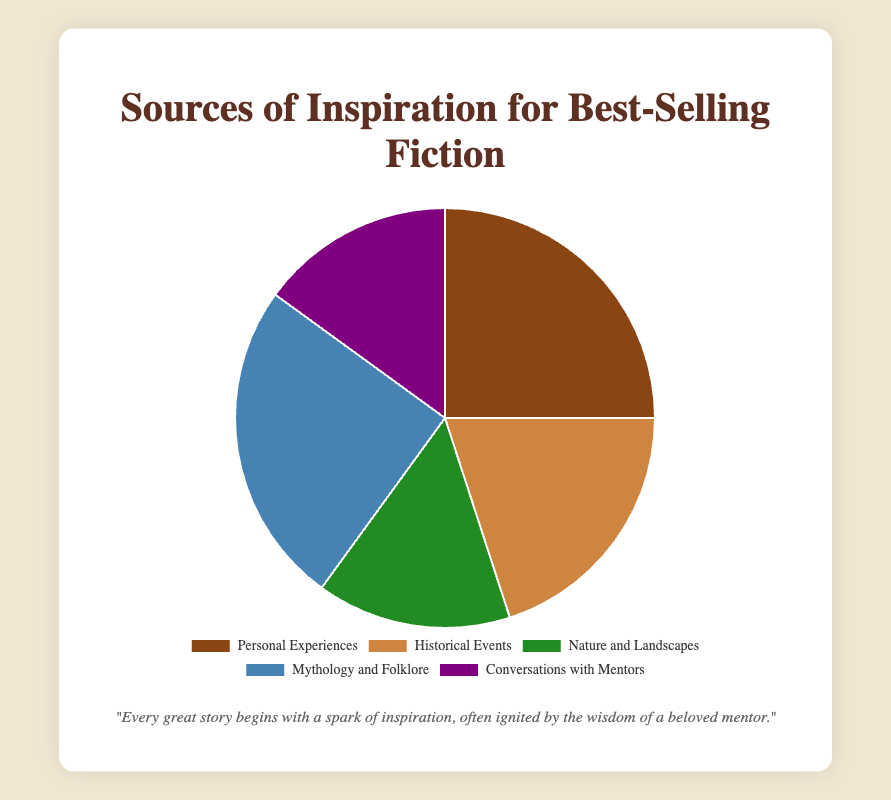What's the most common source of inspiration? The figure shows various percentages for different sources of inspiration, and the highest percentage is the one used to determine the most common source. Both "Personal Experiences" and "Mythology and Folklore" share the highest percentage of 25% each.
Answer: Personal Experiences and Mythology and Folklore Which two sources are equally common and what percentage do they each have? By observing the figure, "Nature and Landscapes" and "Conversations with Mentors" both have the same percentage.
Answer: Nature and Landscapes and Conversations with Mentors, 15% What is the combined percentage of inspiration from "Personal Experiences" and "Mythology and Folklore"? The figure shows that both "Personal Experiences" and "Mythology and Folklore" each contribute 25%, thus combined they contribute 25% + 25% = 50%.
Answer: 50% What is the percentage difference between the most common and least common sources of inspiration? The most common sources are "Personal Experiences" and "Mythology and Folklore" at 25% each, while the least common sources include "Nature and Landscapes" and "Conversations with Mentors" at 15% each. The difference is 25% - 15% = 10%.
Answer: 10% Which source of inspiration is depicted in green on the chart? The visual attribute of color identifies "Nature and Landscapes" as being depicted in green.
Answer: Nature and Landscapes What percentage of inspiration comes from external sources (defined as not related to personal experiences or conversations with mentors)? To find this, sum the percentages of "Historical Events," "Nature and Landscapes," and "Mythology and Folklore." These are 20%, 15%, and 25%, respectively. 20% + 15% + 25% = 60%.
Answer: 60% Which category has the second highest percentage of inspiration and what is it? By observing the figure, the second highest percentage after the tied 25% categories is "Historical Events" at 20%.
Answer: Historical Events, 20% What is the total percentage covered by sources related to people (personal experiences, conversations with mentors)? Combine the percentages for "Personal Experiences" and "Conversations with Mentors": 25% + 15% = 40%.
Answer: 40% What is the average percentage across all sources of inspiration? To find the average, sum all percentages and divide by the number of sources: (25% + 20% + 15% + 25% + 15%) / 5 = 100% / 5 = 20%.
Answer: 20% 